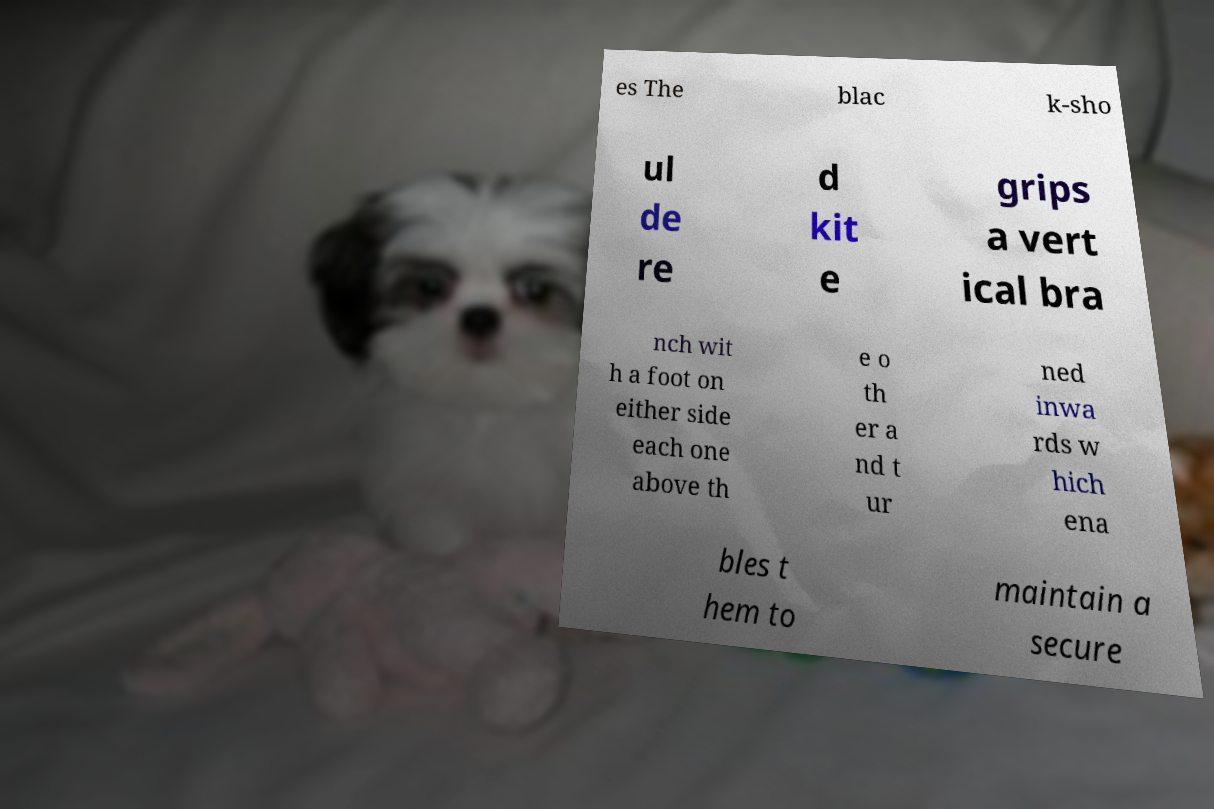There's text embedded in this image that I need extracted. Can you transcribe it verbatim? es The blac k-sho ul de re d kit e grips a vert ical bra nch wit h a foot on either side each one above th e o th er a nd t ur ned inwa rds w hich ena bles t hem to maintain a secure 